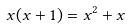Convert formula to latex. <formula><loc_0><loc_0><loc_500><loc_500>x ( x + 1 ) = x ^ { 2 } + x</formula> 